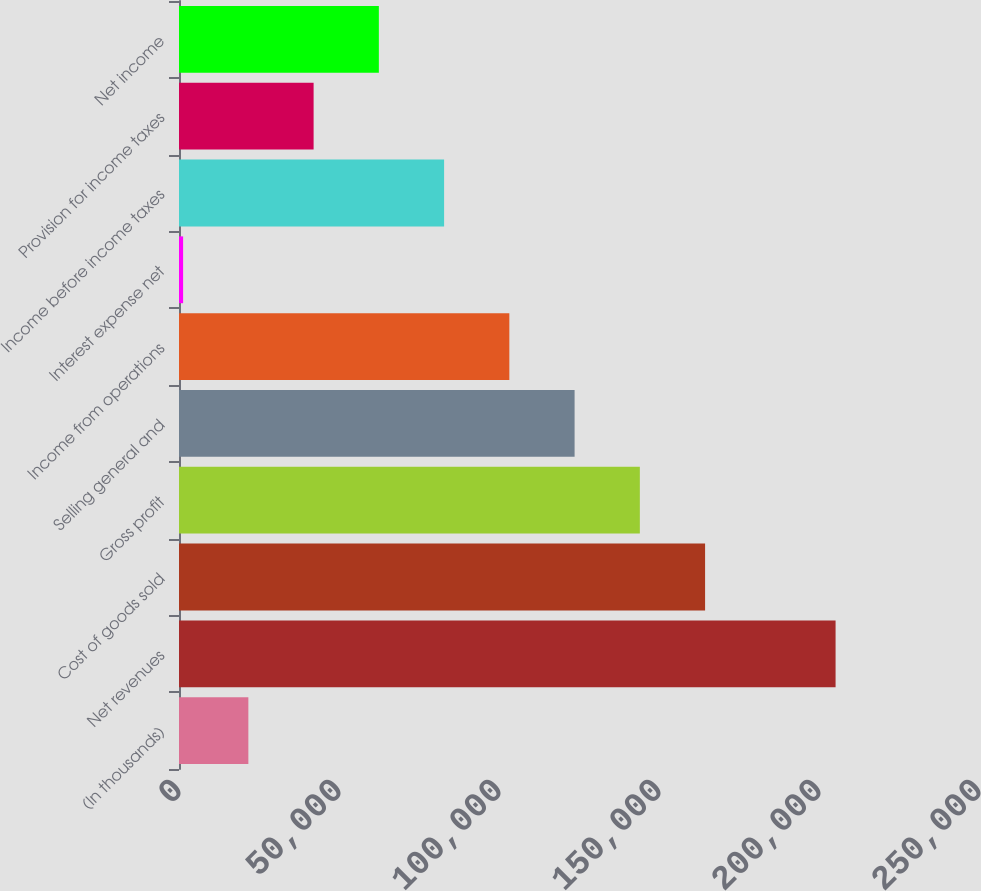Convert chart to OTSL. <chart><loc_0><loc_0><loc_500><loc_500><bar_chart><fcel>(In thousands)<fcel>Net revenues<fcel>Cost of goods sold<fcel>Gross profit<fcel>Selling general and<fcel>Income from operations<fcel>Interest expense net<fcel>Income before income taxes<fcel>Provision for income taxes<fcel>Net income<nl><fcel>21673.7<fcel>205181<fcel>164402<fcel>144012<fcel>123622<fcel>103232<fcel>1284<fcel>82842.8<fcel>42063.4<fcel>62453.1<nl></chart> 